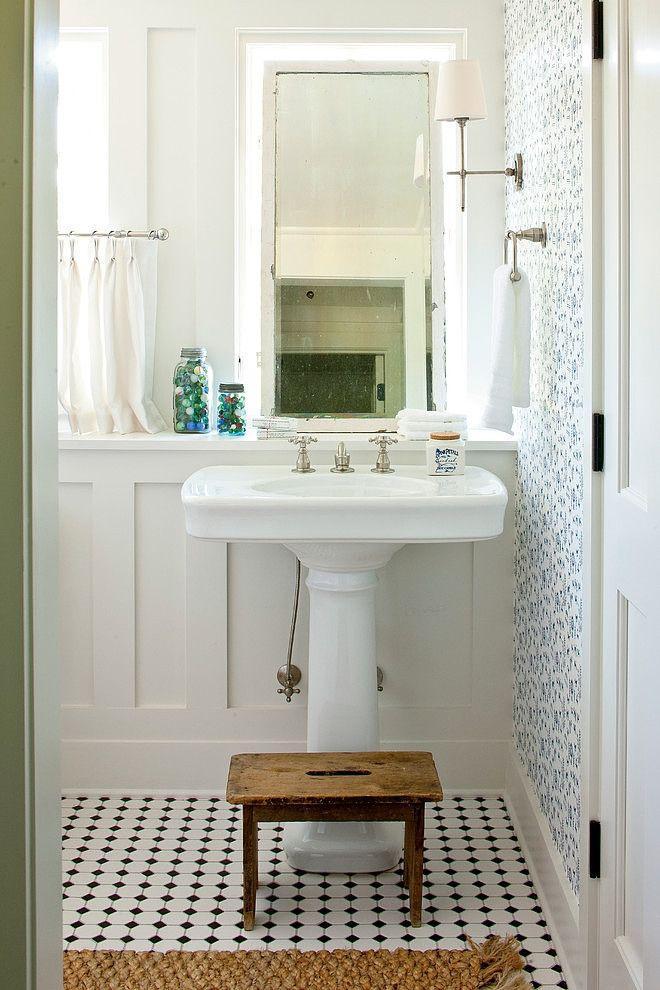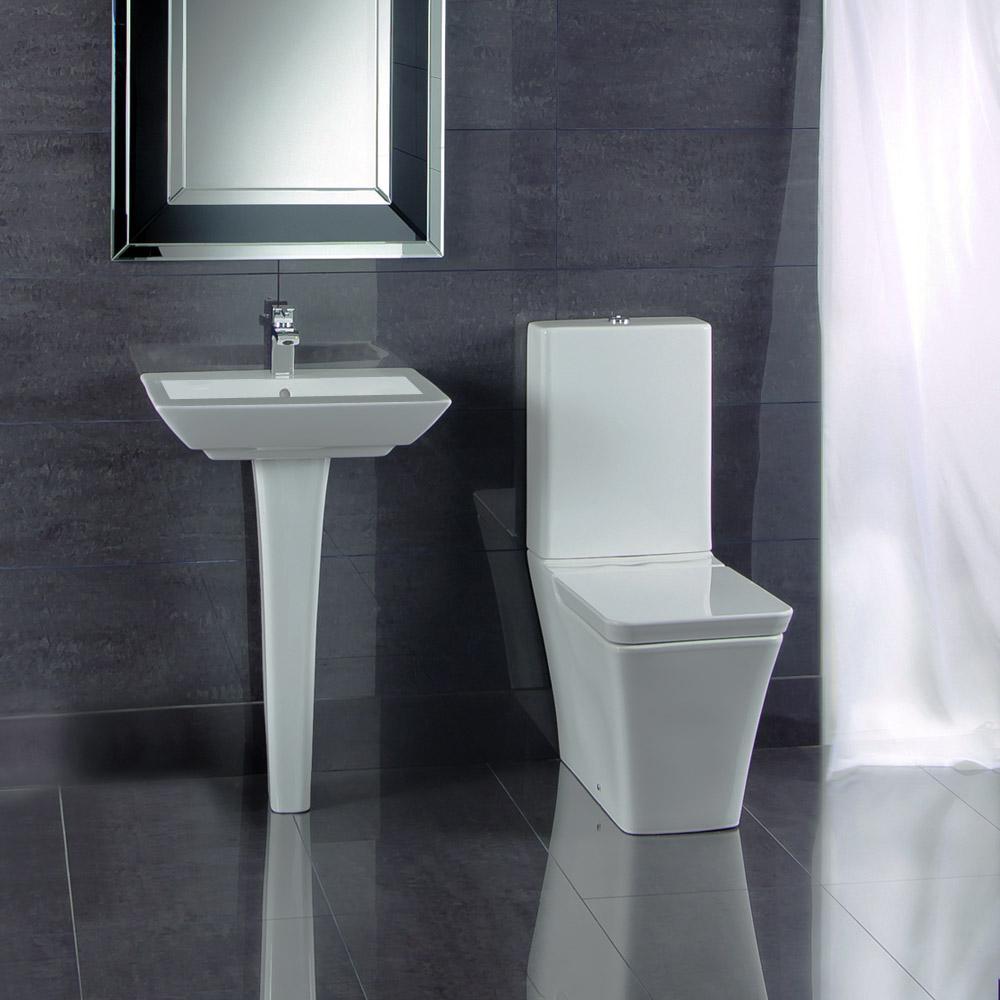The first image is the image on the left, the second image is the image on the right. Analyze the images presented: Is the assertion "A bathroom features a toilet to the right of the sink." valid? Answer yes or no. Yes. 